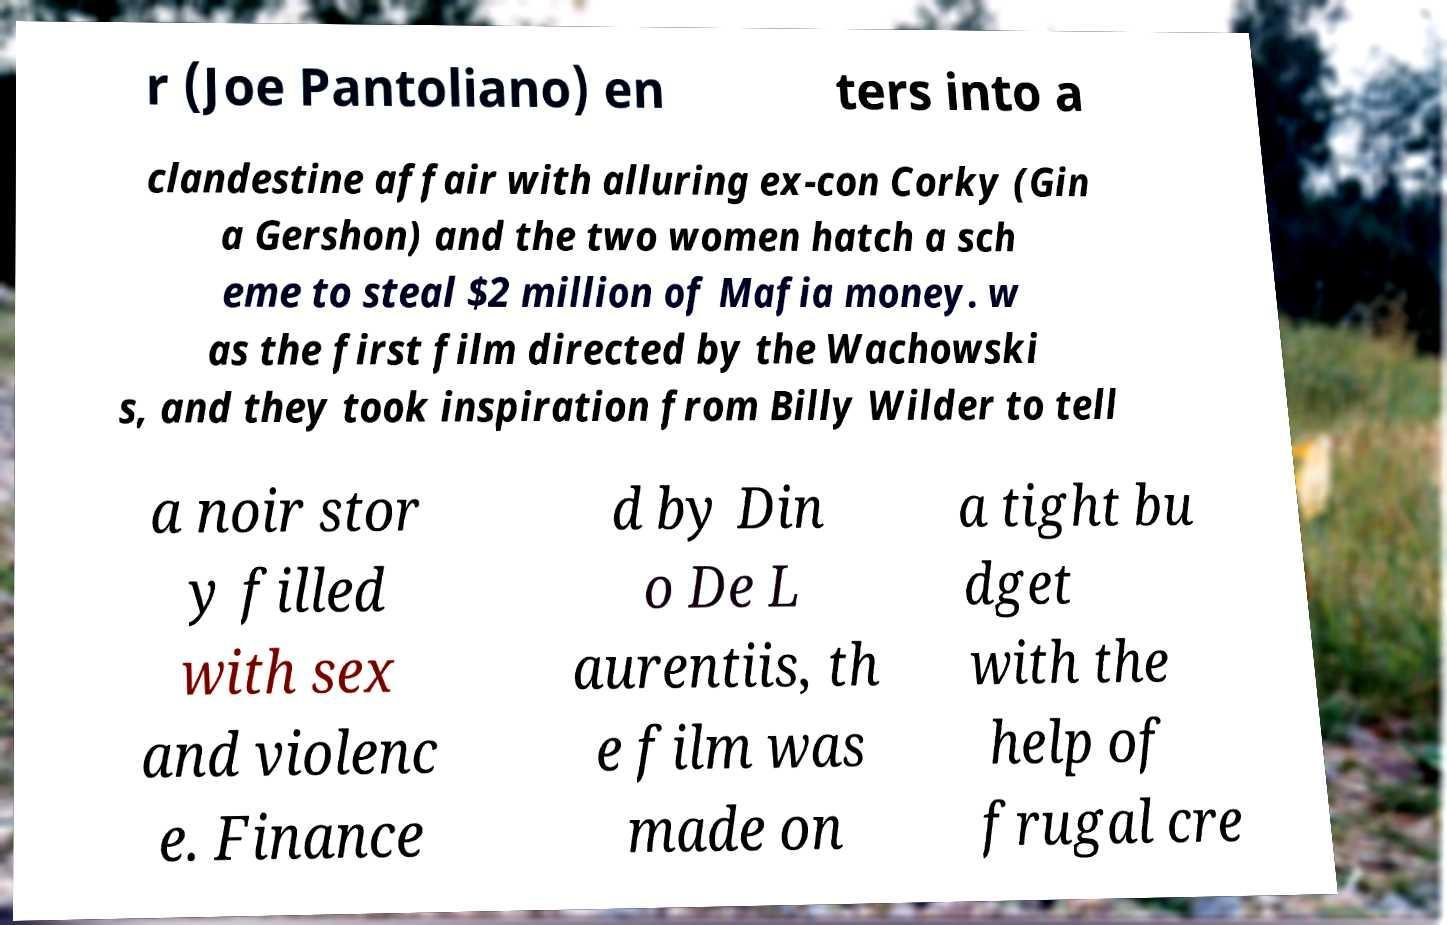What messages or text are displayed in this image? I need them in a readable, typed format. r (Joe Pantoliano) en ters into a clandestine affair with alluring ex-con Corky (Gin a Gershon) and the two women hatch a sch eme to steal $2 million of Mafia money. w as the first film directed by the Wachowski s, and they took inspiration from Billy Wilder to tell a noir stor y filled with sex and violenc e. Finance d by Din o De L aurentiis, th e film was made on a tight bu dget with the help of frugal cre 